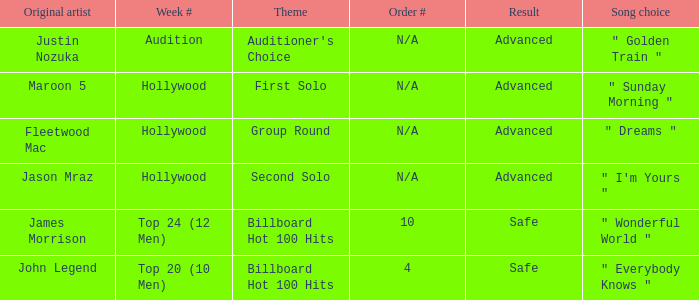What are all of the order # where authentic artist is maroon 5 N/A. Could you help me parse every detail presented in this table? {'header': ['Original artist', 'Week #', 'Theme', 'Order #', 'Result', 'Song choice'], 'rows': [['Justin Nozuka', 'Audition', "Auditioner's Choice", 'N/A', 'Advanced', '" Golden Train "'], ['Maroon 5', 'Hollywood', 'First Solo', 'N/A', 'Advanced', '" Sunday Morning "'], ['Fleetwood Mac', 'Hollywood', 'Group Round', 'N/A', 'Advanced', '" Dreams "'], ['Jason Mraz', 'Hollywood', 'Second Solo', 'N/A', 'Advanced', '" I\'m Yours "'], ['James Morrison', 'Top 24 (12 Men)', 'Billboard Hot 100 Hits', '10', 'Safe', '" Wonderful World "'], ['John Legend', 'Top 20 (10 Men)', 'Billboard Hot 100 Hits', '4', 'Safe', '" Everybody Knows "']]} 